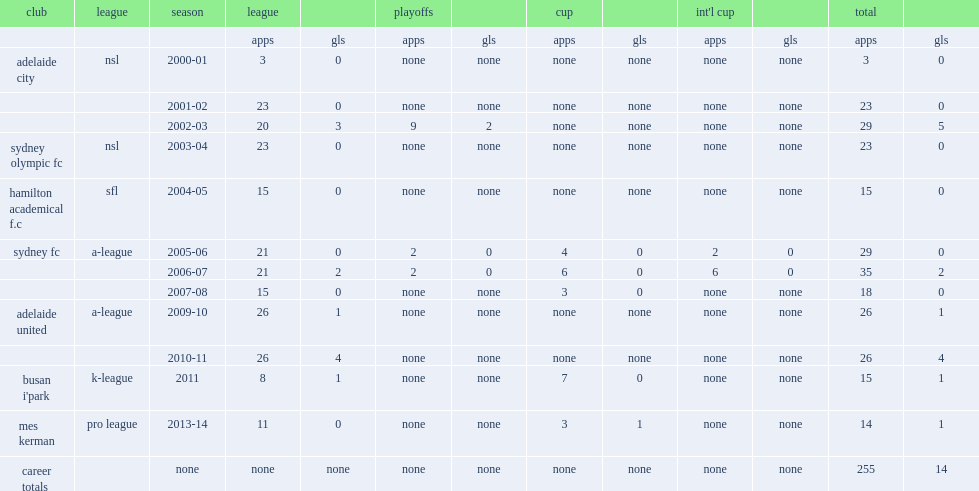Which club did fyfe play for in 2011? Busan i'park. 